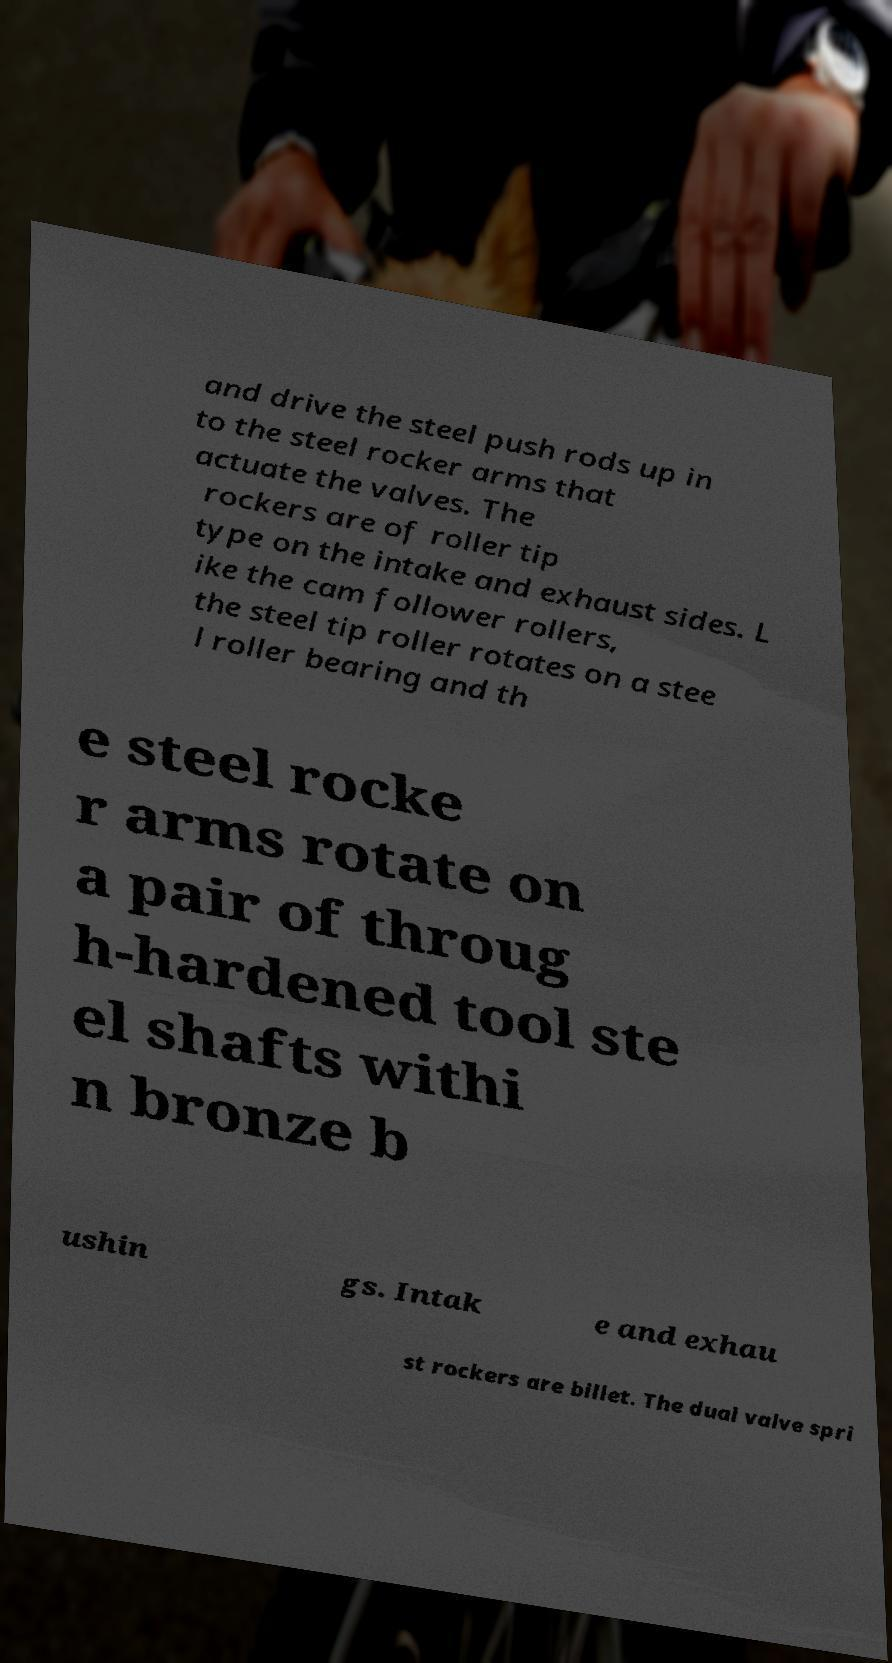Can you read and provide the text displayed in the image?This photo seems to have some interesting text. Can you extract and type it out for me? and drive the steel push rods up in to the steel rocker arms that actuate the valves. The rockers are of roller tip type on the intake and exhaust sides. L ike the cam follower rollers, the steel tip roller rotates on a stee l roller bearing and th e steel rocke r arms rotate on a pair of throug h-hardened tool ste el shafts withi n bronze b ushin gs. Intak e and exhau st rockers are billet. The dual valve spri 